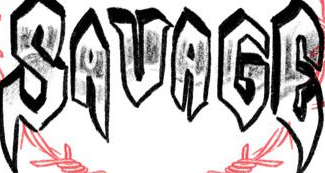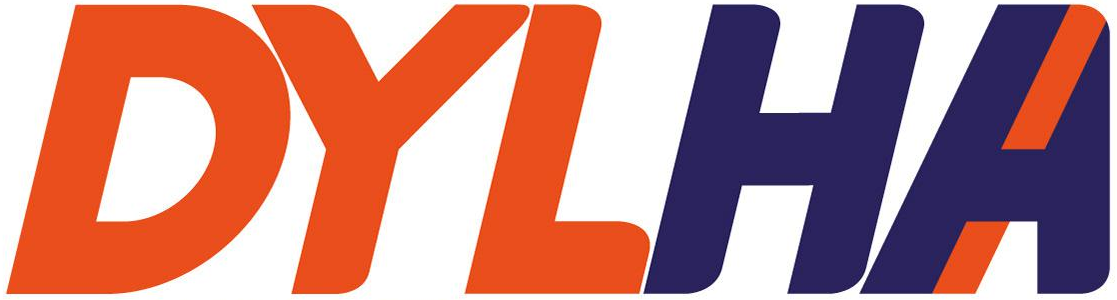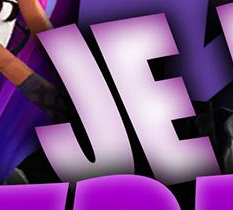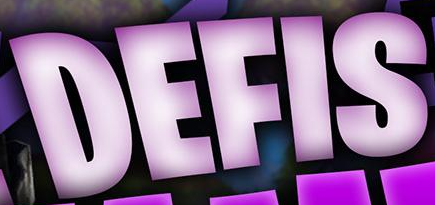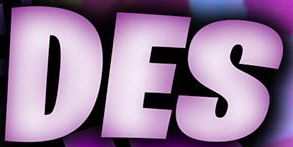Identify the words shown in these images in order, separated by a semicolon. SAVAGE; DYLHA; JE; DEFIS; DES 